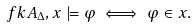<formula> <loc_0><loc_0><loc_500><loc_500>\ f k { A } _ { \Delta } , x \models \varphi \iff \varphi \in x .</formula> 